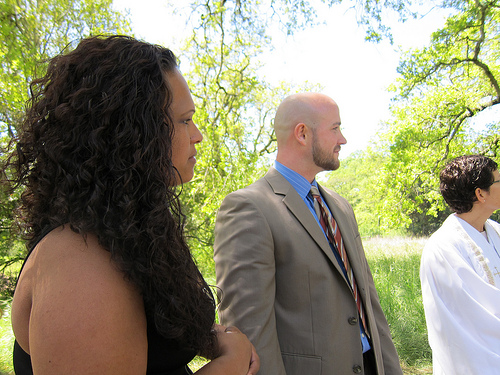<image>
Is there a woman on the man? No. The woman is not positioned on the man. They may be near each other, but the woman is not supported by or resting on top of the man. Where is the woman in relation to the man? Is it next to the man? Yes. The woman is positioned adjacent to the man, located nearby in the same general area. 